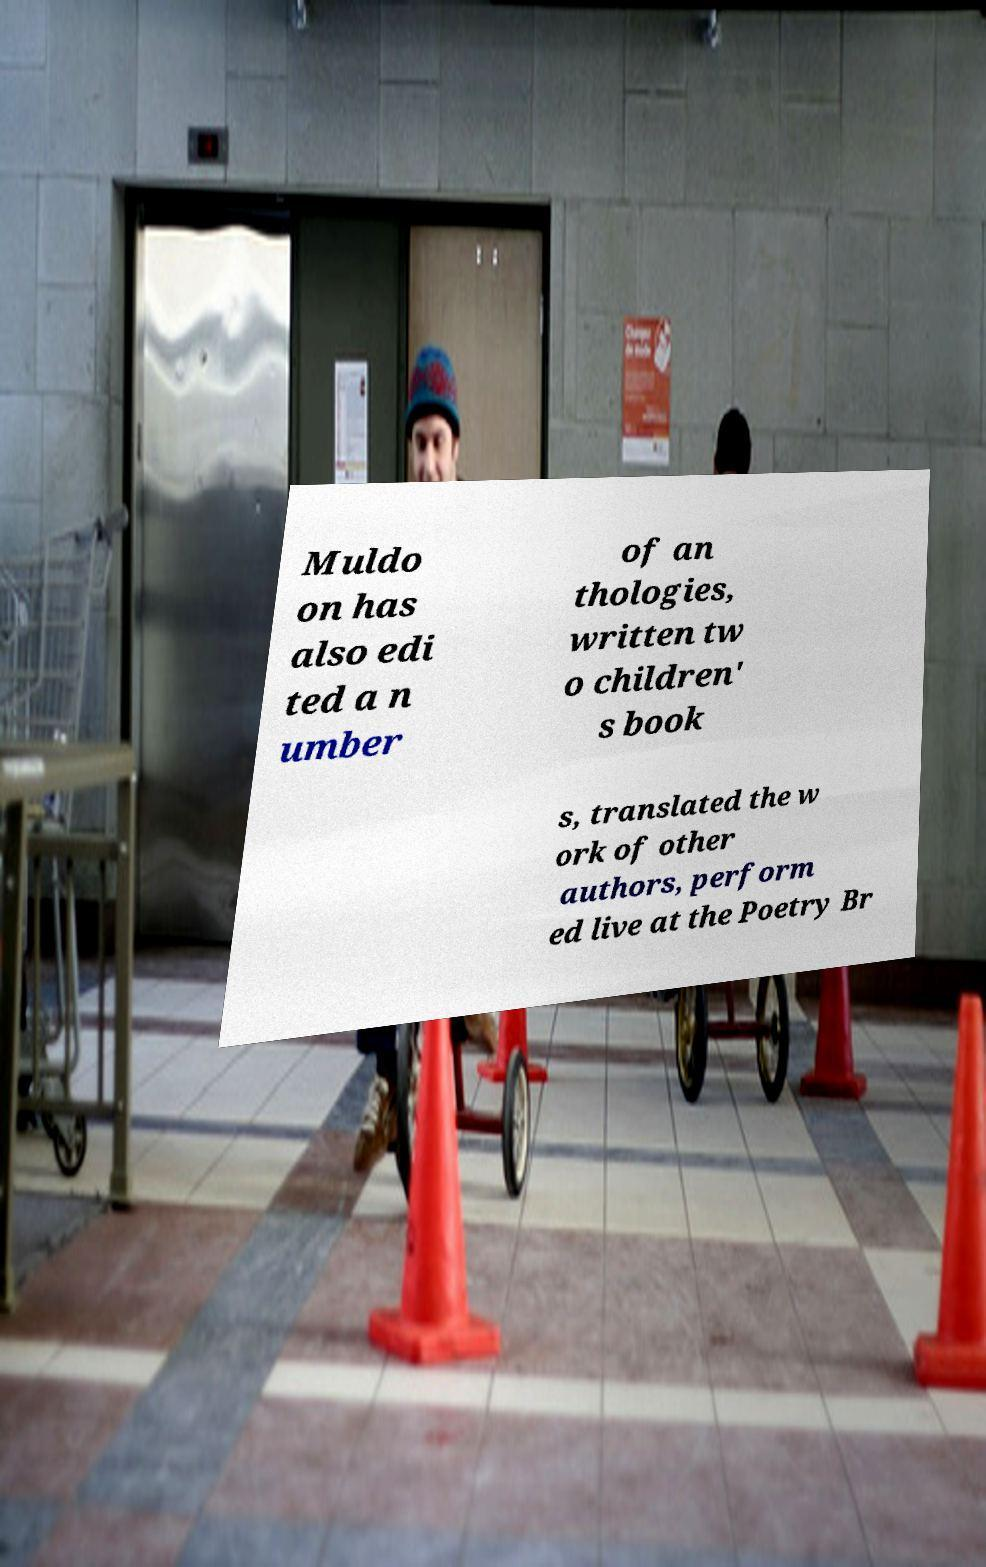I need the written content from this picture converted into text. Can you do that? Muldo on has also edi ted a n umber of an thologies, written tw o children' s book s, translated the w ork of other authors, perform ed live at the Poetry Br 